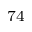Convert formula to latex. <formula><loc_0><loc_0><loc_500><loc_500>^ { 7 4 }</formula> 